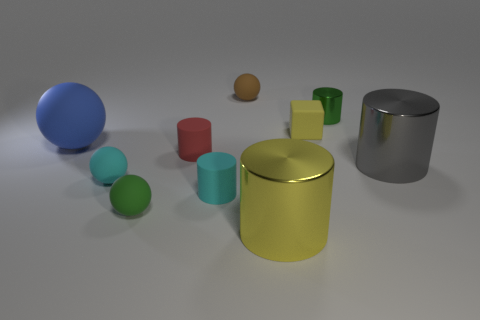How does the size comparison of the objects contribute to the perception of depth in the image? The varied sizes of the objects in the image play a significant role in conveying depth. The smaller objects in the foreground present as closer to the viewer, while the progressively larger objects towards the background create a sense of receding space. This size gradient, alongside the overlapping positioning of objects and the soft-focus areas, amplifies the three-dimensional perspective of the scene. 